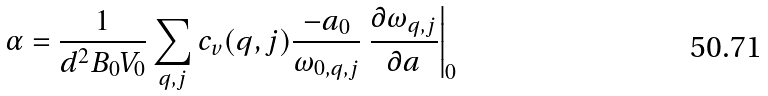Convert formula to latex. <formula><loc_0><loc_0><loc_500><loc_500>\alpha = \frac { 1 } { d ^ { 2 } B _ { 0 } V _ { 0 } } \sum _ { q , j } c _ { v } ( q , j ) \frac { - a _ { 0 } } { \omega _ { 0 , q , j } } \left . \frac { \partial \omega _ { q , j } } { \partial a } \right | _ { 0 }</formula> 